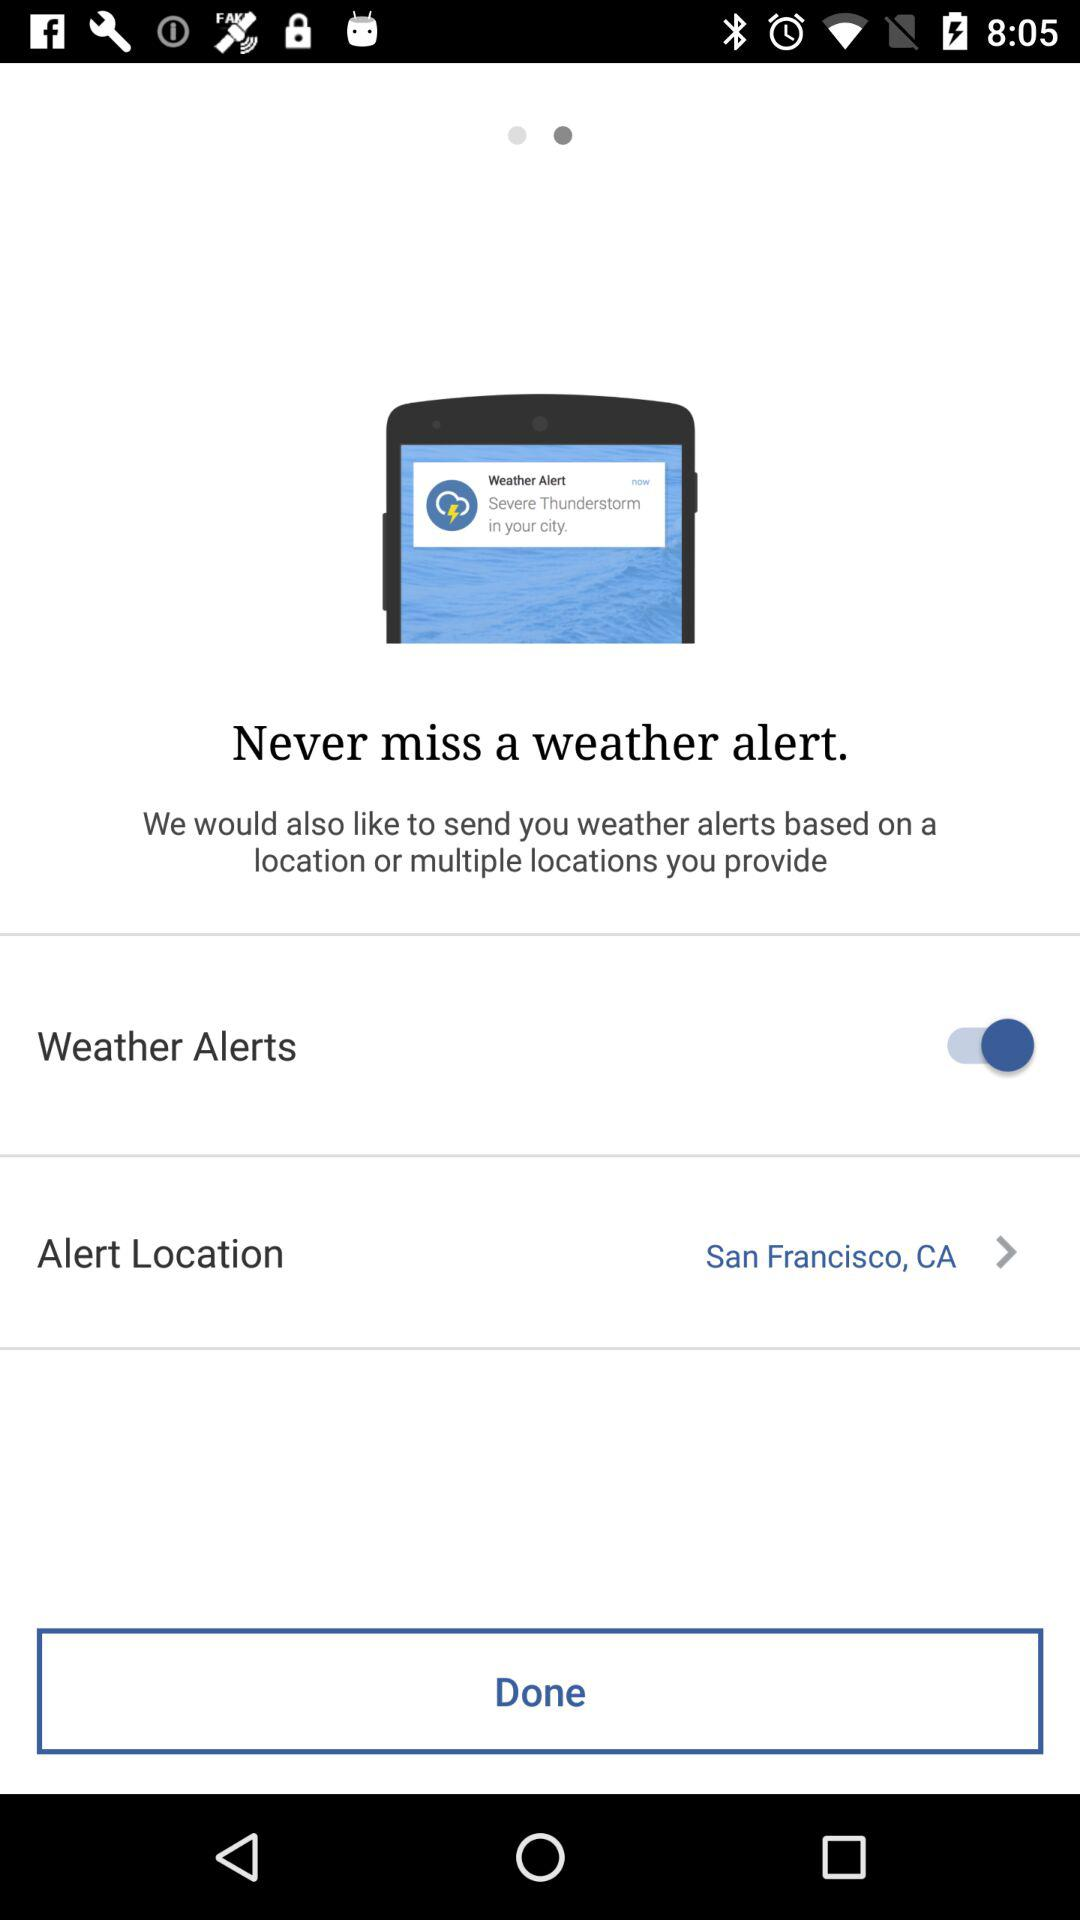What is the status of "Weather Alerts"? The status is "on". 